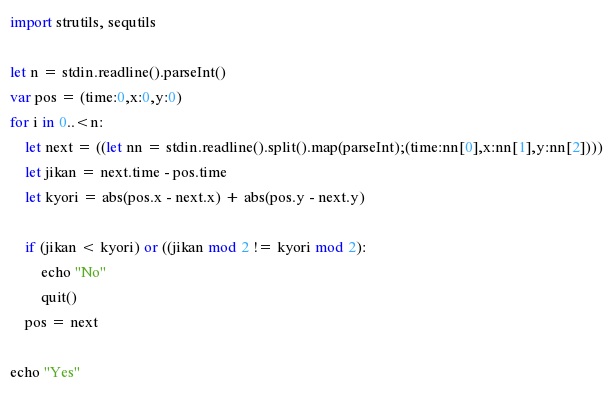Convert code to text. <code><loc_0><loc_0><loc_500><loc_500><_Nim_>import strutils, sequtils

let n = stdin.readline().parseInt()
var pos = (time:0,x:0,y:0)
for i in 0..<n:
    let next = ((let nn = stdin.readline().split().map(parseInt);(time:nn[0],x:nn[1],y:nn[2])))
    let jikan = next.time - pos.time
    let kyori = abs(pos.x - next.x) + abs(pos.y - next.y)

    if (jikan < kyori) or ((jikan mod 2 != kyori mod 2):
        echo "No"
        quit()
    pos = next

echo "Yes"</code> 